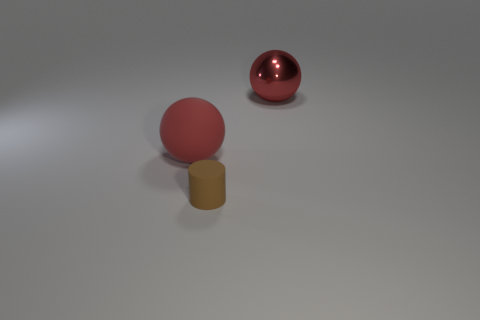Add 1 tiny rubber cylinders. How many objects exist? 4 Subtract 1 spheres. How many spheres are left? 1 Subtract all balls. How many objects are left? 1 Subtract all small cyan cylinders. Subtract all large metal balls. How many objects are left? 2 Add 2 large red balls. How many large red balls are left? 4 Add 2 tiny red objects. How many tiny red objects exist? 2 Subtract 0 purple spheres. How many objects are left? 3 Subtract all cyan spheres. Subtract all yellow cylinders. How many spheres are left? 2 